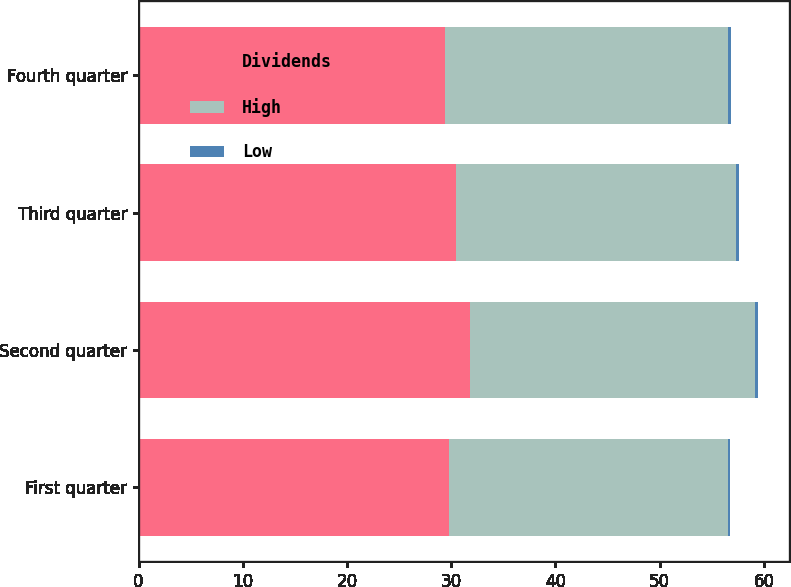Convert chart. <chart><loc_0><loc_0><loc_500><loc_500><stacked_bar_chart><ecel><fcel>First quarter<fcel>Second quarter<fcel>Third quarter<fcel>Fourth quarter<nl><fcel>Dividends<fcel>29.74<fcel>31.79<fcel>30.41<fcel>29.4<nl><fcel>High<fcel>26.77<fcel>27.38<fcel>26.9<fcel>27.14<nl><fcel>Low<fcel>0.27<fcel>0.28<fcel>0.28<fcel>0.28<nl></chart> 